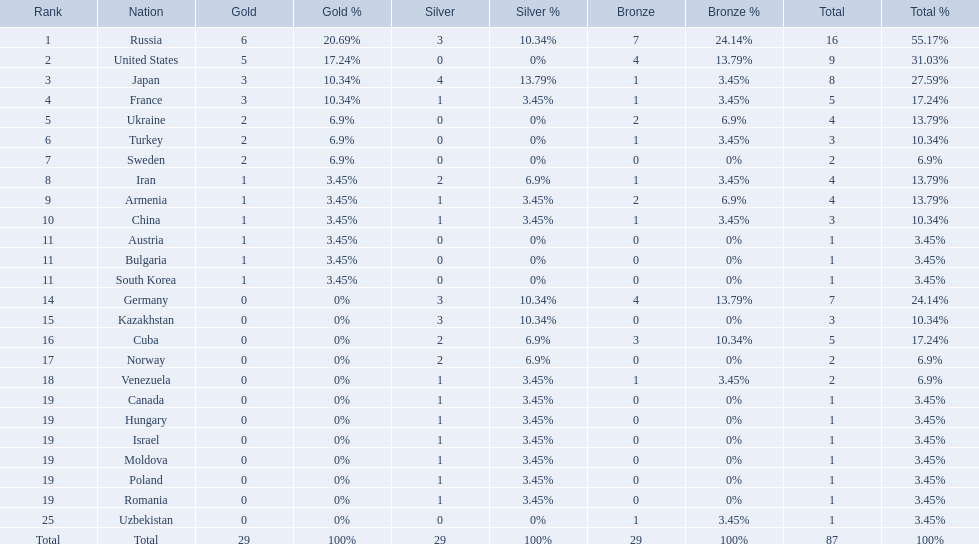How many countries competed? Israel. How many total medals did russia win? 16. What country won only 1 medal? Uzbekistan. Can you give me this table as a dict? {'header': ['Rank', 'Nation', 'Gold', 'Gold %', 'Silver', 'Silver %', 'Bronze', 'Bronze %', 'Total', 'Total %'], 'rows': [['1', 'Russia', '6', '20.69%', '3', '10.34%', '7', '24.14%', '16', '55.17%'], ['2', 'United States', '5', '17.24%', '0', '0%', '4', '13.79%', '9', '31.03%'], ['3', 'Japan', '3', '10.34%', '4', '13.79%', '1', '3.45%', '8', '27.59%'], ['4', 'France', '3', '10.34%', '1', '3.45%', '1', '3.45%', '5', '17.24%'], ['5', 'Ukraine', '2', '6.9%', '0', '0%', '2', '6.9%', '4', '13.79%'], ['6', 'Turkey', '2', '6.9%', '0', '0%', '1', '3.45%', '3', '10.34%'], ['7', 'Sweden', '2', '6.9%', '0', '0%', '0', '0%', '2', '6.9%'], ['8', 'Iran', '1', '3.45%', '2', '6.9%', '1', '3.45%', '4', '13.79%'], ['9', 'Armenia', '1', '3.45%', '1', '3.45%', '2', '6.9%', '4', '13.79%'], ['10', 'China', '1', '3.45%', '1', '3.45%', '1', '3.45%', '3', '10.34%'], ['11', 'Austria', '1', '3.45%', '0', '0%', '0', '0%', '1', '3.45%'], ['11', 'Bulgaria', '1', '3.45%', '0', '0%', '0', '0%', '1', '3.45%'], ['11', 'South Korea', '1', '3.45%', '0', '0%', '0', '0%', '1', '3.45%'], ['14', 'Germany', '0', '0%', '3', '10.34%', '4', '13.79%', '7', '24.14%'], ['15', 'Kazakhstan', '0', '0%', '3', '10.34%', '0', '0%', '3', '10.34%'], ['16', 'Cuba', '0', '0%', '2', '6.9%', '3', '10.34%', '5', '17.24%'], ['17', 'Norway', '0', '0%', '2', '6.9%', '0', '0%', '2', '6.9%'], ['18', 'Venezuela', '0', '0%', '1', '3.45%', '1', '3.45%', '2', '6.9%'], ['19', 'Canada', '0', '0%', '1', '3.45%', '0', '0%', '1', '3.45%'], ['19', 'Hungary', '0', '0%', '1', '3.45%', '0', '0%', '1', '3.45%'], ['19', 'Israel', '0', '0%', '1', '3.45%', '0', '0%', '1', '3.45%'], ['19', 'Moldova', '0', '0%', '1', '3.45%', '0', '0%', '1', '3.45%'], ['19', 'Poland', '0', '0%', '1', '3.45%', '0', '0%', '1', '3.45%'], ['19', 'Romania', '0', '0%', '1', '3.45%', '0', '0%', '1', '3.45%'], ['25', 'Uzbekistan', '0', '0%', '0', '0%', '1', '3.45%', '1', '3.45%'], ['Total', 'Total', '29', '100%', '29', '100%', '29', '100%', '87', '100%']]} 